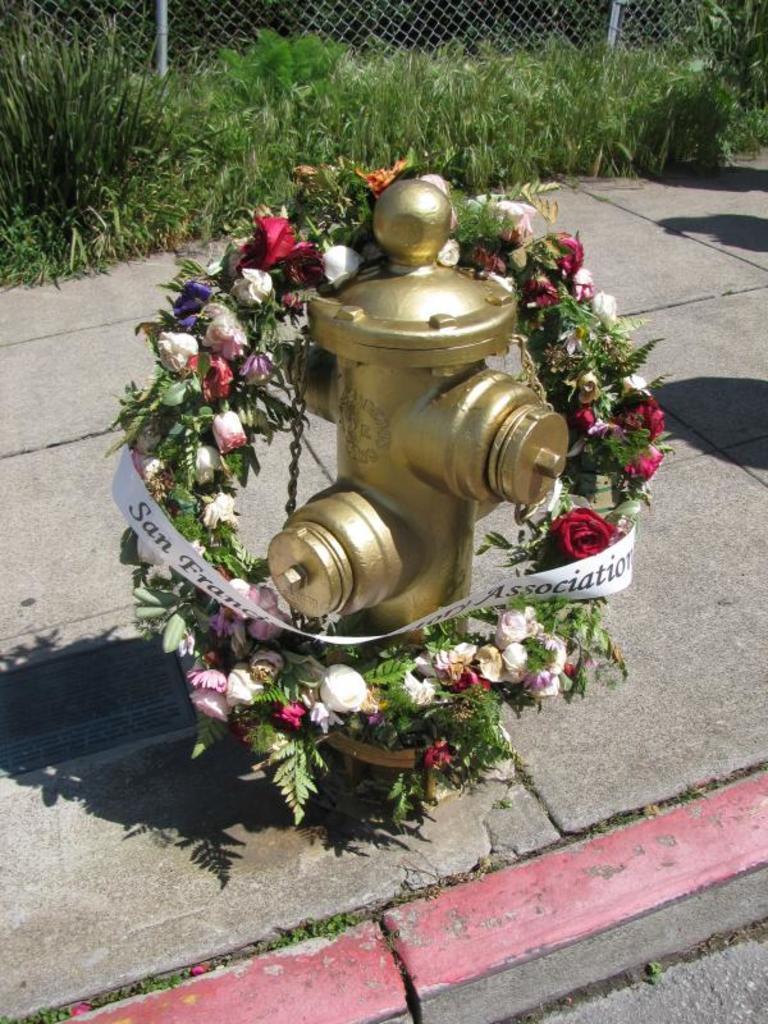Describe this image in one or two sentences. In this picture we can see a fire hydrant with the wreath. Behind the fire hydrant, there are plants and the wire fencing. 